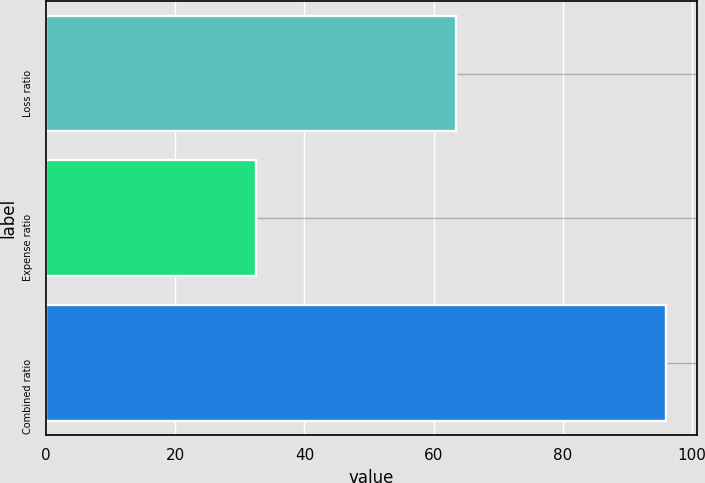Convert chart. <chart><loc_0><loc_0><loc_500><loc_500><bar_chart><fcel>Loss ratio<fcel>Expense ratio<fcel>Combined ratio<nl><fcel>63.5<fcel>32.5<fcel>96<nl></chart> 